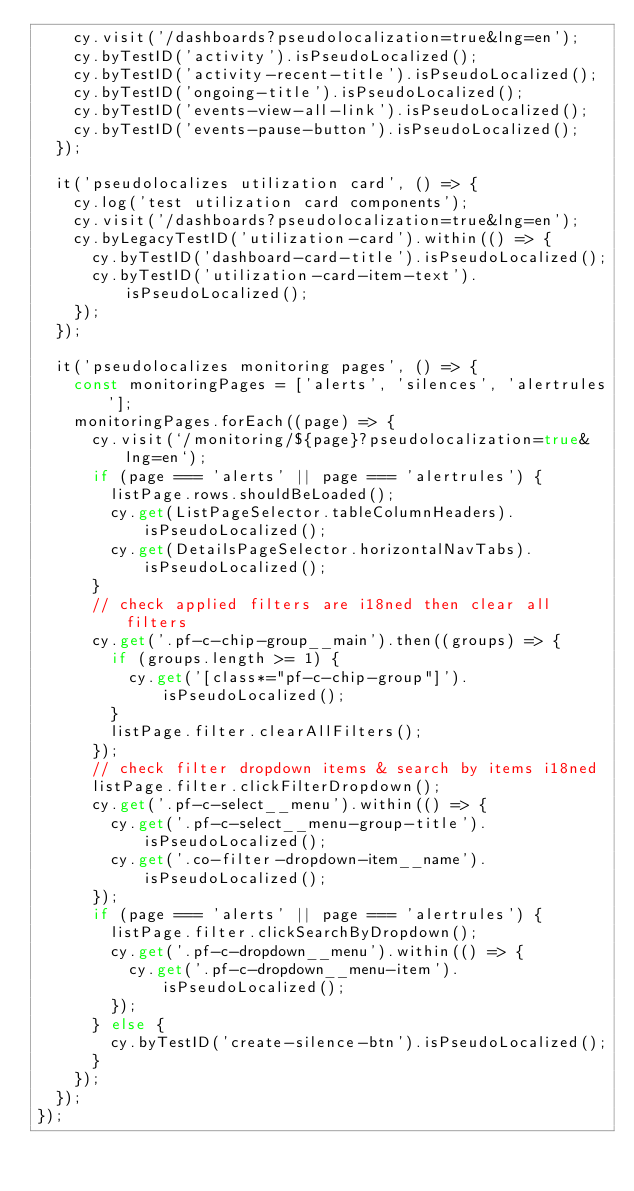Convert code to text. <code><loc_0><loc_0><loc_500><loc_500><_TypeScript_>    cy.visit('/dashboards?pseudolocalization=true&lng=en');
    cy.byTestID('activity').isPseudoLocalized();
    cy.byTestID('activity-recent-title').isPseudoLocalized();
    cy.byTestID('ongoing-title').isPseudoLocalized();
    cy.byTestID('events-view-all-link').isPseudoLocalized();
    cy.byTestID('events-pause-button').isPseudoLocalized();
  });

  it('pseudolocalizes utilization card', () => {
    cy.log('test utilization card components');
    cy.visit('/dashboards?pseudolocalization=true&lng=en');
    cy.byLegacyTestID('utilization-card').within(() => {
      cy.byTestID('dashboard-card-title').isPseudoLocalized();
      cy.byTestID('utilization-card-item-text').isPseudoLocalized();
    });
  });

  it('pseudolocalizes monitoring pages', () => {
    const monitoringPages = ['alerts', 'silences', 'alertrules'];
    monitoringPages.forEach((page) => {
      cy.visit(`/monitoring/${page}?pseudolocalization=true&lng=en`);
      if (page === 'alerts' || page === 'alertrules') {
        listPage.rows.shouldBeLoaded();
        cy.get(ListPageSelector.tableColumnHeaders).isPseudoLocalized();
        cy.get(DetailsPageSelector.horizontalNavTabs).isPseudoLocalized();
      }
      // check applied filters are i18ned then clear all filters
      cy.get('.pf-c-chip-group__main').then((groups) => {
        if (groups.length >= 1) {
          cy.get('[class*="pf-c-chip-group"]').isPseudoLocalized();
        }
        listPage.filter.clearAllFilters();
      });
      // check filter dropdown items & search by items i18ned
      listPage.filter.clickFilterDropdown();
      cy.get('.pf-c-select__menu').within(() => {
        cy.get('.pf-c-select__menu-group-title').isPseudoLocalized();
        cy.get('.co-filter-dropdown-item__name').isPseudoLocalized();
      });
      if (page === 'alerts' || page === 'alertrules') {
        listPage.filter.clickSearchByDropdown();
        cy.get('.pf-c-dropdown__menu').within(() => {
          cy.get('.pf-c-dropdown__menu-item').isPseudoLocalized();
        });
      } else {
        cy.byTestID('create-silence-btn').isPseudoLocalized();
      }
    });
  });
});
</code> 